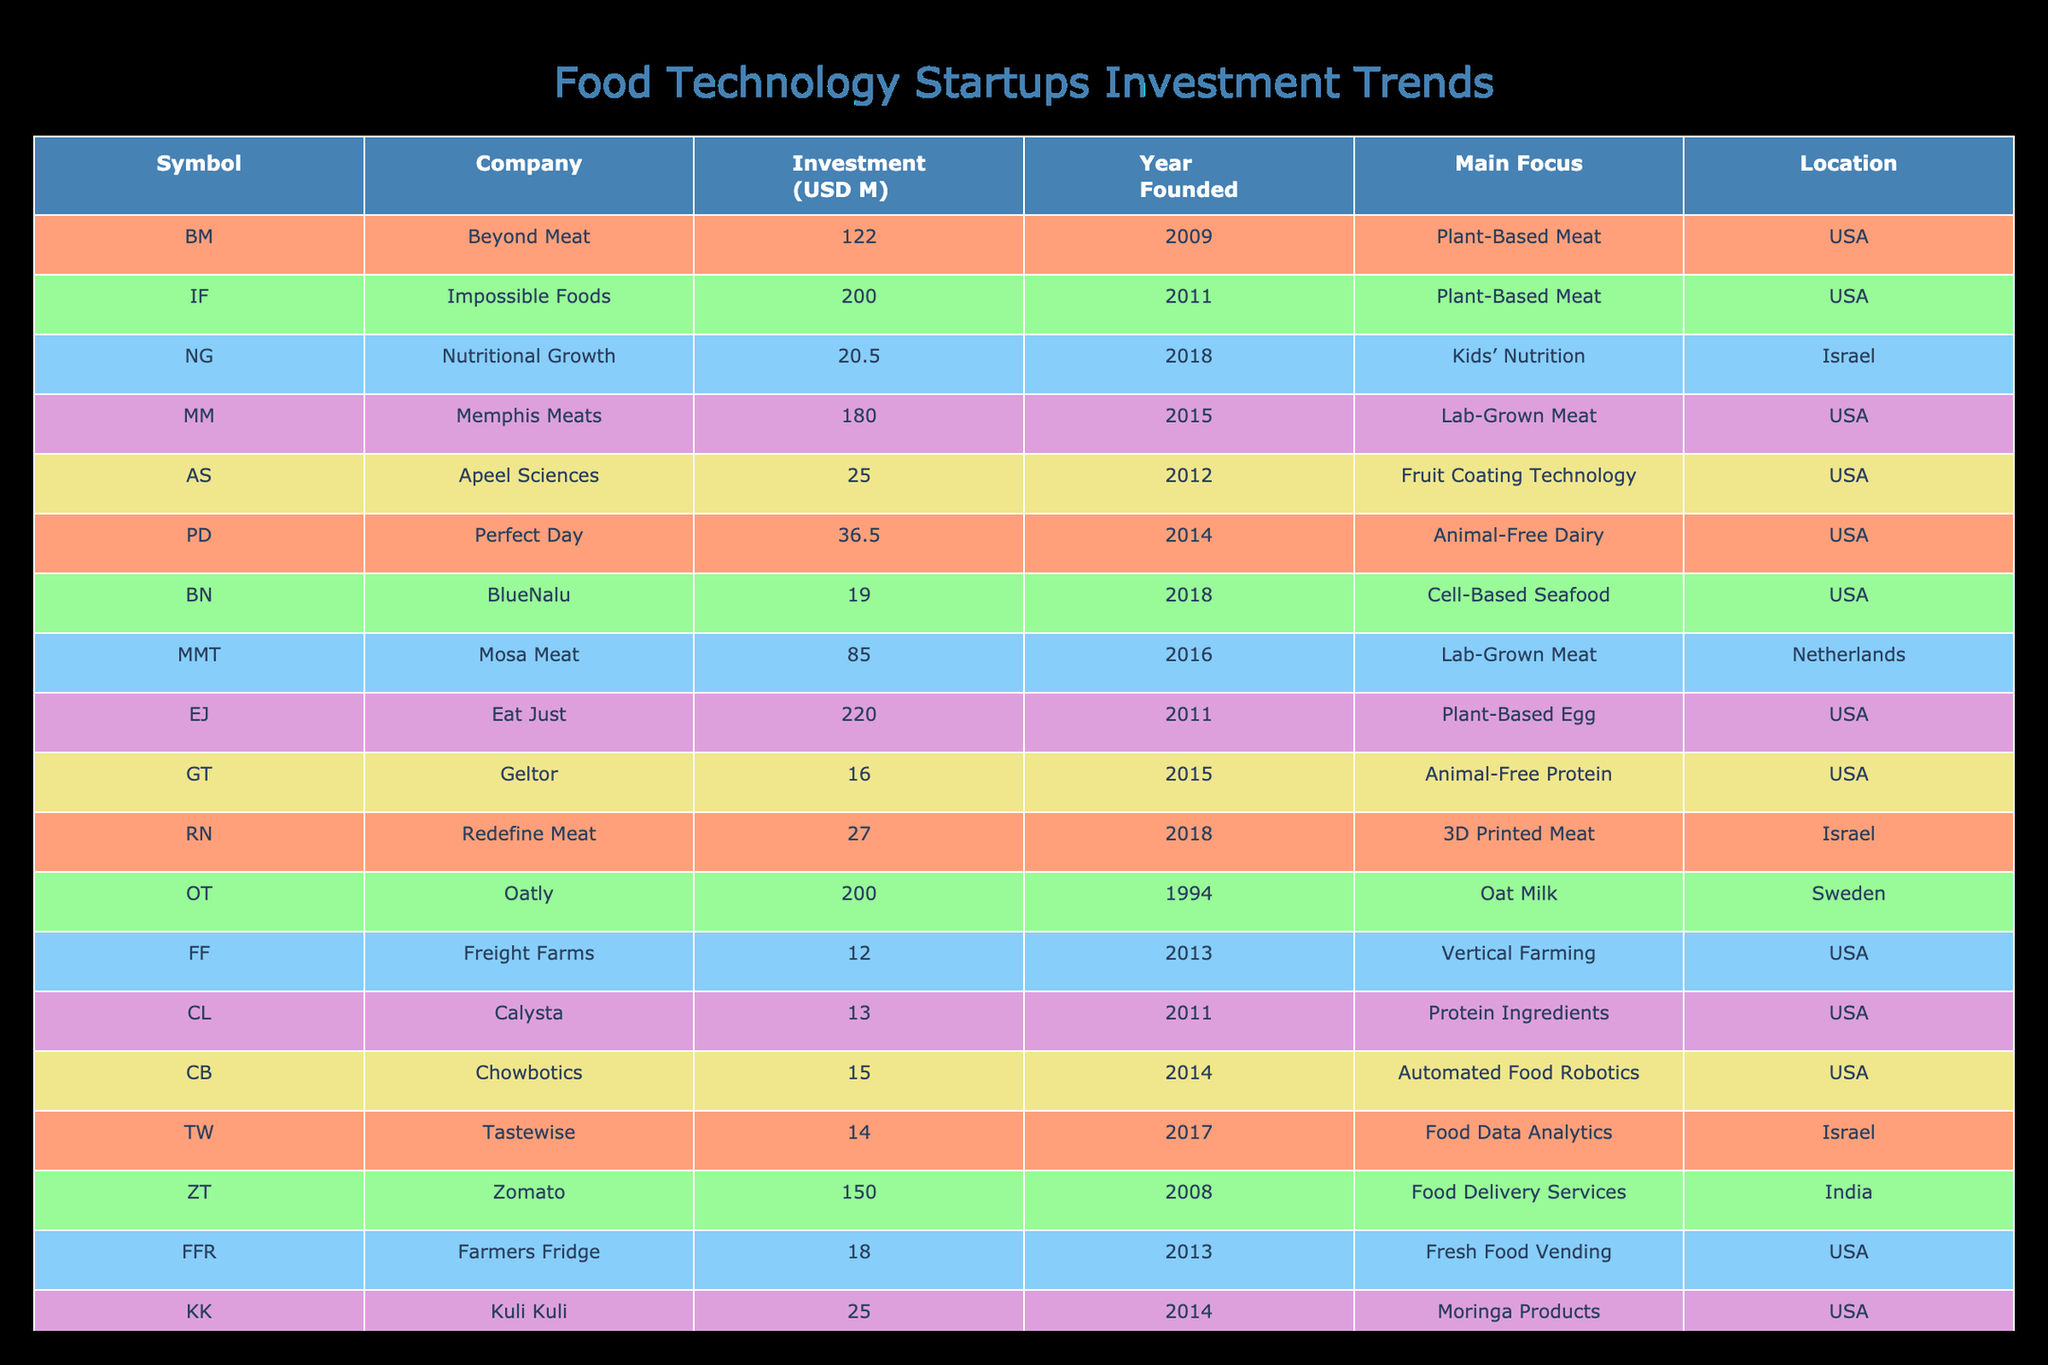What is the investment amount of Beyond Meat? Beyond Meat is listed in the table with an investment amount of 122 million USD. The specific column for the investment amount provides this figure directly.
Answer: 122 million USD Which startup has the highest investment amount? By reviewing the investment amounts in the table, Impossible Foods has the highest investment with 200 million USD.
Answer: 200 million USD How many companies were founded after 2015? A count of the Year Founded column shows that there are 7 companies established after 2015 (Nutritional Growth, BlueNalu, Mosa Meat, Tastewise, Redefine Meat, Farmers Fridge, and Kuli Kuli).
Answer: 7 companies What is the total investment amount for all companies focused on Lab-Grown Meat? The total investment for Lab-Grown Meat focuses on two companies: Memphis Meats (180 million USD) and Mosa Meat (85 million USD). Adding these gives 180 + 85 = 265 million USD.
Answer: 265 million USD Is there a company specializing in Fruit Coating Technology in the table? Yes, Apeel Sciences focuses on Fruit Coating Technology and it is mentioned in the table under Main Focus.
Answer: Yes What is the average investment amount of companies based in the USA? The investments for USA-based companies are 122, 200, 180, 25, 36.5, 14, 15, 18, and 25 million USD, which add up to 731 million USD. There are 9 companies, so the average is 731 million USD divided by 9, resulting in approximately 81.22 million USD.
Answer: Approximately 81.22 million USD Which company is located in Israel and what is its investment amount? The companies listed as located in Israel are Nutritional Growth and Redefine Meat. Their respective investment amounts are 20.5 million USD and 27 million USD.
Answer: Nutritional Growth (20.5 million USD), Redefine Meat (27 million USD) List all companies that focus on Plant-Based products. The companies focusing on Plant-Based products are Beyond Meat, Impossible Foods, Eat Just, and Calysta. Their investments are 122, 200, 220, and 13 million USD respectively.
Answer: Beyond Meat, Impossible Foods, Eat Just, Calysta How does the investment amount of Oatly compare to that of Zomato? Oatly has an investment amount of 200 million USD, while Zomato has 150 million USD. Comparing them, Oatly has a higher investment by 50 million USD.
Answer: Oatly has 50 million USD more than Zomato 